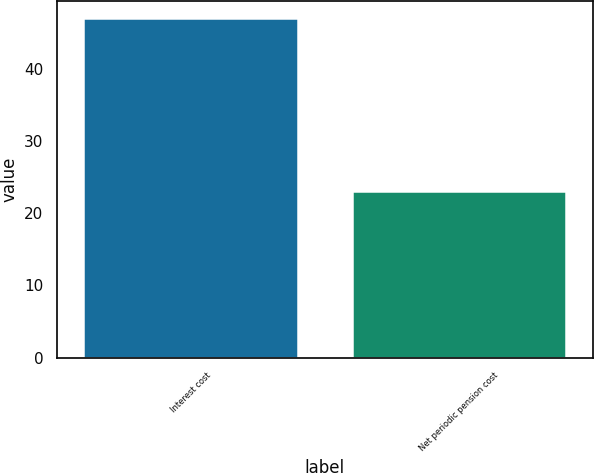Convert chart to OTSL. <chart><loc_0><loc_0><loc_500><loc_500><bar_chart><fcel>Interest cost<fcel>Net periodic pension cost<nl><fcel>47<fcel>23<nl></chart> 